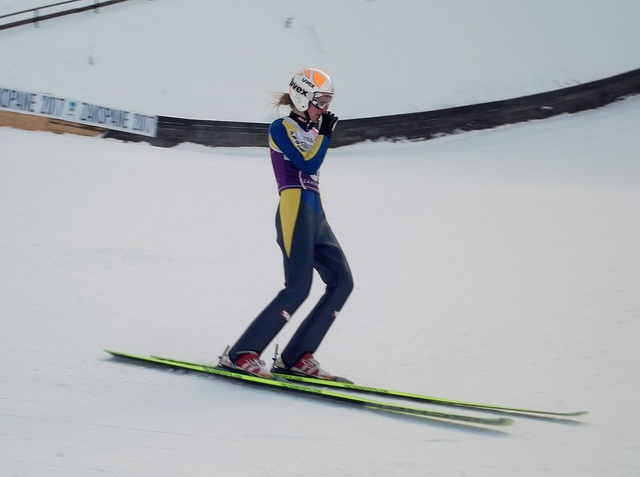Describe the objects in this image and their specific colors. I can see people in darkgray, black, navy, and gray tones and skis in darkgray, lightgreen, gray, black, and beige tones in this image. 